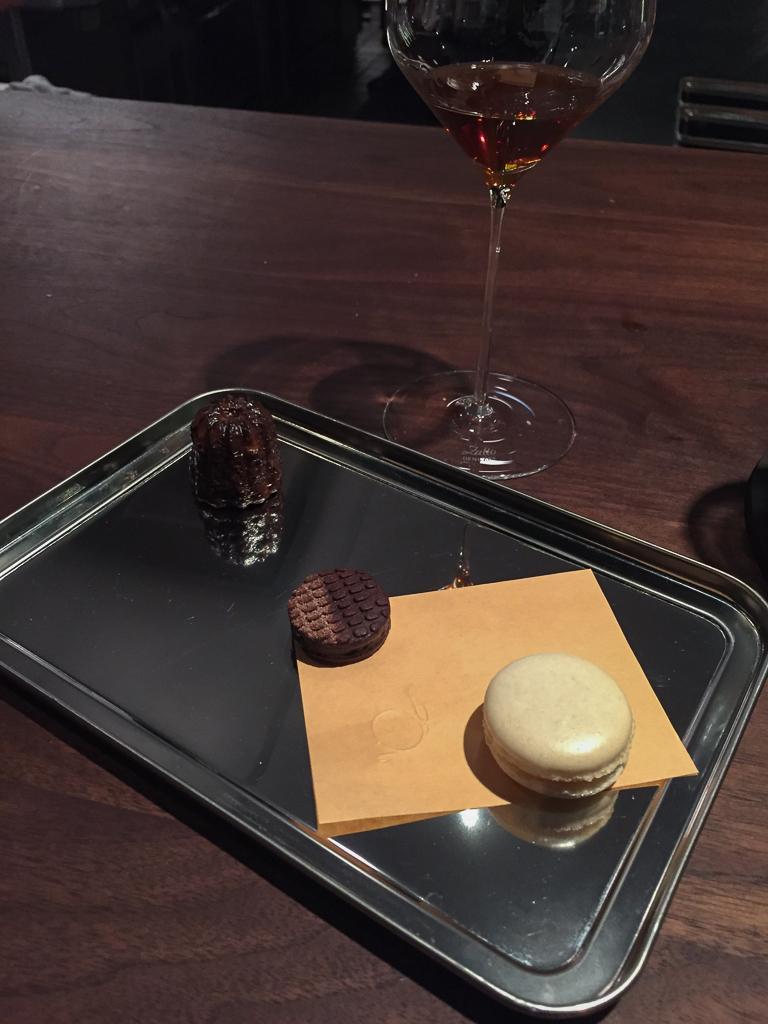In one or two sentences, can you explain what this image depicts? In this image there are 2 chocolate cookies and a dessert in a plate and a wine glass placed in a table. 